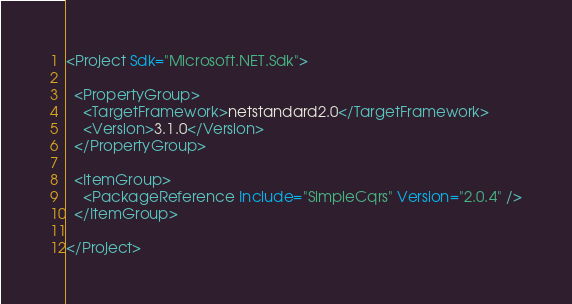Convert code to text. <code><loc_0><loc_0><loc_500><loc_500><_XML_><Project Sdk="Microsoft.NET.Sdk">

  <PropertyGroup>
    <TargetFramework>netstandard2.0</TargetFramework>
    <Version>3.1.0</Version>
  </PropertyGroup>

  <ItemGroup>
    <PackageReference Include="SimpleCqrs" Version="2.0.4" />
  </ItemGroup>

</Project>
</code> 